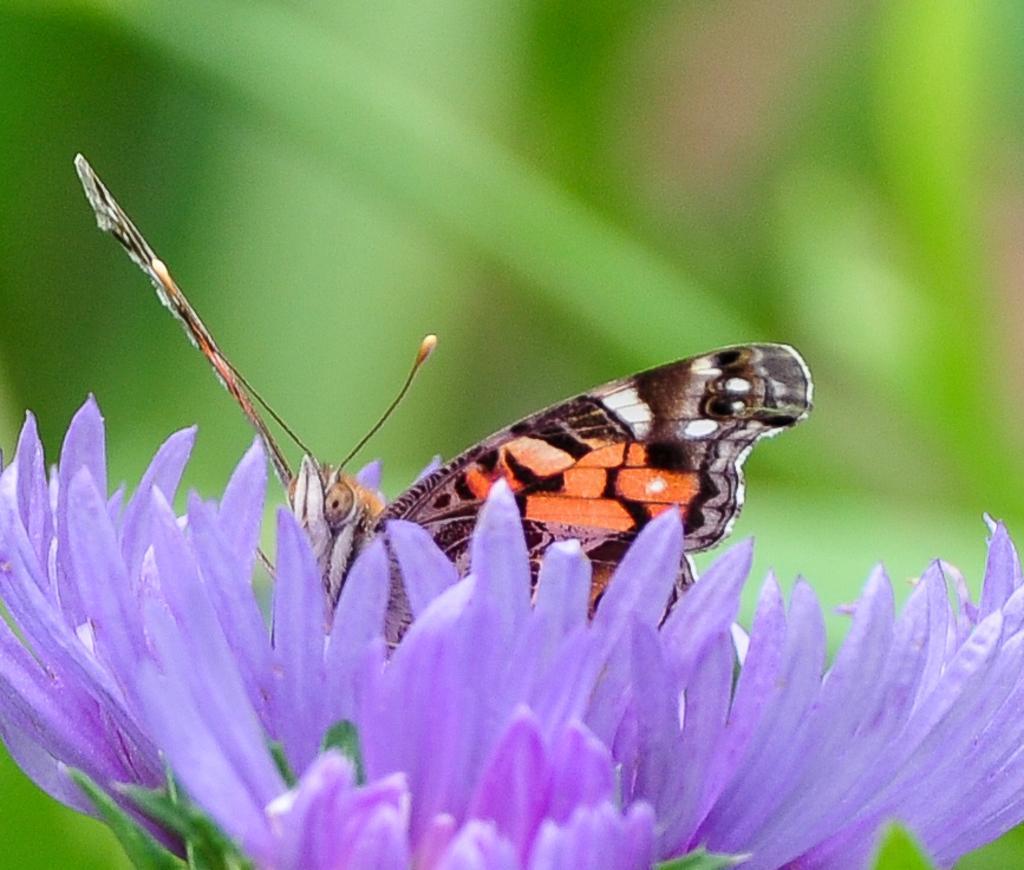Please provide a concise description of this image. In this picture we can see a butterfly on a flower and in the background it is blurry. 